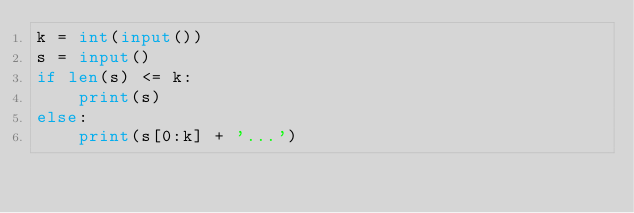<code> <loc_0><loc_0><loc_500><loc_500><_Python_>k = int(input())
s = input()
if len(s) <= k:
    print(s)
else:
    print(s[0:k] + '...')</code> 